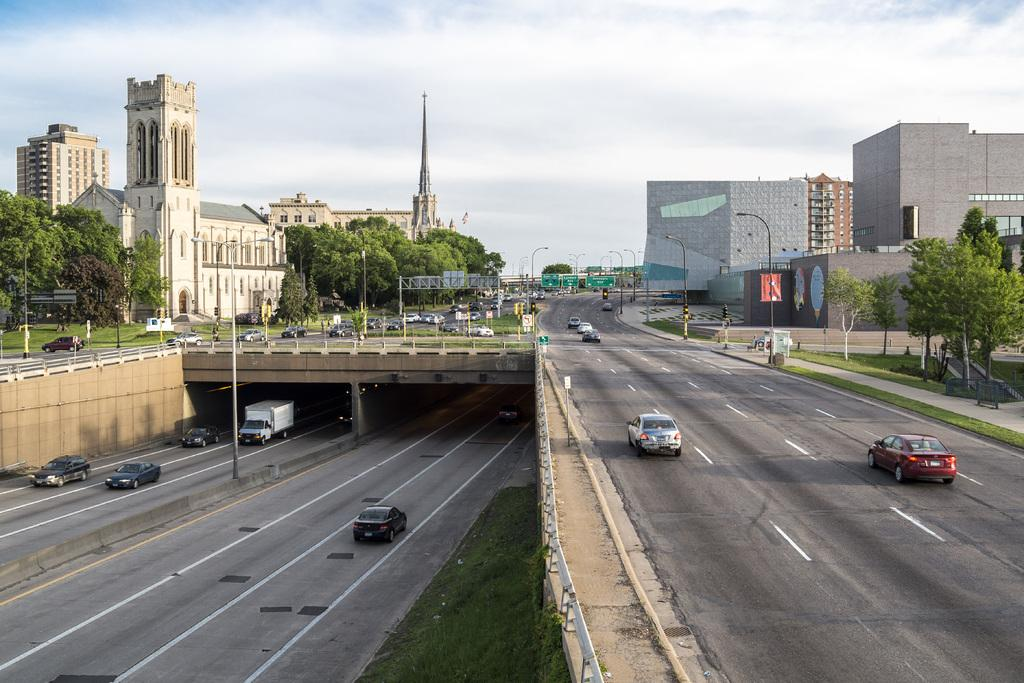What is happening on the road in the image? There are vehicles on the road in the image. How are the vehicles positioned on the road? The vehicles are going on either side of the road. What can be seen in the background of the image? There are buildings in the background of the image. Where are the buildings located in relation to the land? The buildings are on either side of the land. What is in front of the buildings? Trees are present in front of the buildings. What is visible above the scene in the image? The sky is visible in the image, and clouds are present in the sky. Can you tell me how many maids are working in the field in the image? There is no field or maid present in the image. What type of side dish is being served with the vehicles on the road? There is no side dish present in the image; it features vehicles on a road with buildings and trees in the background. 